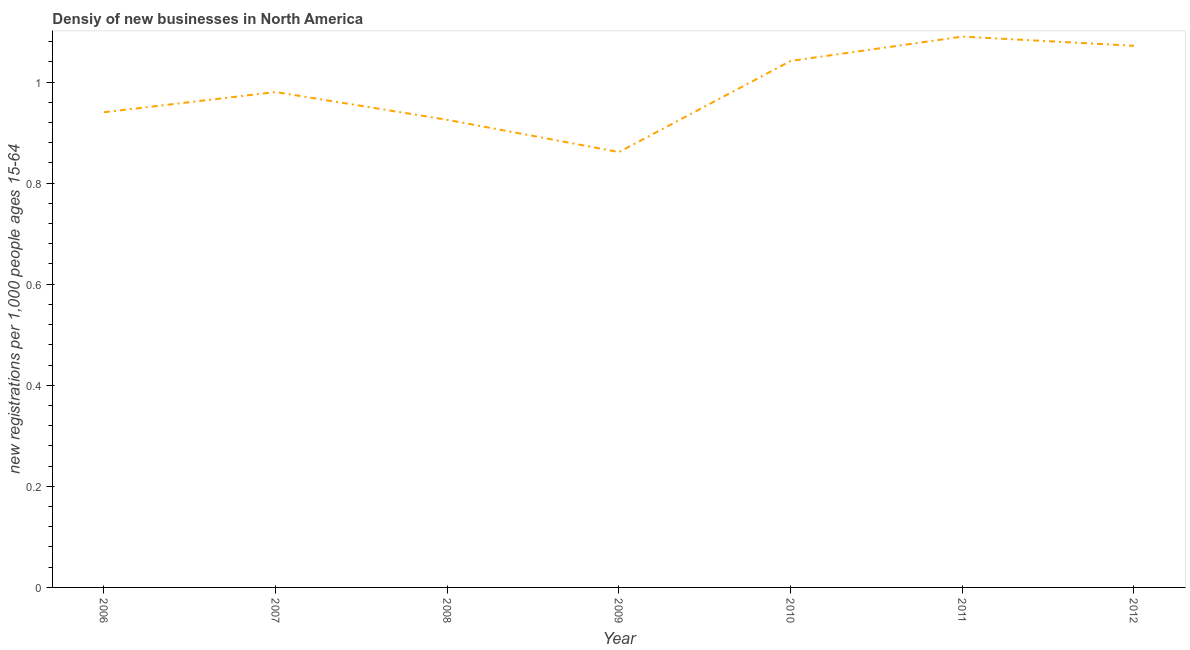What is the density of new business in 2012?
Your response must be concise. 1.07. Across all years, what is the maximum density of new business?
Your response must be concise. 1.09. Across all years, what is the minimum density of new business?
Provide a short and direct response. 0.86. What is the sum of the density of new business?
Keep it short and to the point. 6.91. What is the difference between the density of new business in 2008 and 2011?
Offer a very short reply. -0.16. What is the average density of new business per year?
Provide a short and direct response. 0.99. What is the median density of new business?
Give a very brief answer. 0.98. What is the ratio of the density of new business in 2007 to that in 2011?
Ensure brevity in your answer.  0.9. Is the density of new business in 2008 less than that in 2010?
Offer a very short reply. Yes. Is the difference between the density of new business in 2008 and 2009 greater than the difference between any two years?
Offer a terse response. No. What is the difference between the highest and the second highest density of new business?
Your answer should be very brief. 0.02. Is the sum of the density of new business in 2007 and 2012 greater than the maximum density of new business across all years?
Ensure brevity in your answer.  Yes. What is the difference between the highest and the lowest density of new business?
Offer a very short reply. 0.23. In how many years, is the density of new business greater than the average density of new business taken over all years?
Provide a succinct answer. 3. Does the density of new business monotonically increase over the years?
Your response must be concise. No. What is the difference between two consecutive major ticks on the Y-axis?
Your answer should be compact. 0.2. Does the graph contain grids?
Your answer should be compact. No. What is the title of the graph?
Your answer should be compact. Densiy of new businesses in North America. What is the label or title of the Y-axis?
Offer a very short reply. New registrations per 1,0 people ages 15-64. What is the new registrations per 1,000 people ages 15-64 of 2006?
Offer a very short reply. 0.94. What is the new registrations per 1,000 people ages 15-64 in 2007?
Ensure brevity in your answer.  0.98. What is the new registrations per 1,000 people ages 15-64 of 2008?
Your answer should be compact. 0.93. What is the new registrations per 1,000 people ages 15-64 in 2009?
Keep it short and to the point. 0.86. What is the new registrations per 1,000 people ages 15-64 in 2010?
Offer a very short reply. 1.04. What is the new registrations per 1,000 people ages 15-64 in 2011?
Provide a succinct answer. 1.09. What is the new registrations per 1,000 people ages 15-64 in 2012?
Provide a short and direct response. 1.07. What is the difference between the new registrations per 1,000 people ages 15-64 in 2006 and 2007?
Offer a terse response. -0.04. What is the difference between the new registrations per 1,000 people ages 15-64 in 2006 and 2008?
Your response must be concise. 0.02. What is the difference between the new registrations per 1,000 people ages 15-64 in 2006 and 2009?
Provide a short and direct response. 0.08. What is the difference between the new registrations per 1,000 people ages 15-64 in 2006 and 2010?
Offer a terse response. -0.1. What is the difference between the new registrations per 1,000 people ages 15-64 in 2006 and 2011?
Your answer should be very brief. -0.15. What is the difference between the new registrations per 1,000 people ages 15-64 in 2006 and 2012?
Ensure brevity in your answer.  -0.13. What is the difference between the new registrations per 1,000 people ages 15-64 in 2007 and 2008?
Offer a terse response. 0.06. What is the difference between the new registrations per 1,000 people ages 15-64 in 2007 and 2009?
Provide a succinct answer. 0.12. What is the difference between the new registrations per 1,000 people ages 15-64 in 2007 and 2010?
Ensure brevity in your answer.  -0.06. What is the difference between the new registrations per 1,000 people ages 15-64 in 2007 and 2011?
Provide a short and direct response. -0.11. What is the difference between the new registrations per 1,000 people ages 15-64 in 2007 and 2012?
Offer a very short reply. -0.09. What is the difference between the new registrations per 1,000 people ages 15-64 in 2008 and 2009?
Ensure brevity in your answer.  0.06. What is the difference between the new registrations per 1,000 people ages 15-64 in 2008 and 2010?
Give a very brief answer. -0.12. What is the difference between the new registrations per 1,000 people ages 15-64 in 2008 and 2011?
Your response must be concise. -0.16. What is the difference between the new registrations per 1,000 people ages 15-64 in 2008 and 2012?
Ensure brevity in your answer.  -0.15. What is the difference between the new registrations per 1,000 people ages 15-64 in 2009 and 2010?
Your answer should be compact. -0.18. What is the difference between the new registrations per 1,000 people ages 15-64 in 2009 and 2011?
Your answer should be very brief. -0.23. What is the difference between the new registrations per 1,000 people ages 15-64 in 2009 and 2012?
Keep it short and to the point. -0.21. What is the difference between the new registrations per 1,000 people ages 15-64 in 2010 and 2011?
Your response must be concise. -0.05. What is the difference between the new registrations per 1,000 people ages 15-64 in 2010 and 2012?
Offer a very short reply. -0.03. What is the difference between the new registrations per 1,000 people ages 15-64 in 2011 and 2012?
Give a very brief answer. 0.02. What is the ratio of the new registrations per 1,000 people ages 15-64 in 2006 to that in 2007?
Your answer should be compact. 0.96. What is the ratio of the new registrations per 1,000 people ages 15-64 in 2006 to that in 2009?
Give a very brief answer. 1.09. What is the ratio of the new registrations per 1,000 people ages 15-64 in 2006 to that in 2010?
Keep it short and to the point. 0.9. What is the ratio of the new registrations per 1,000 people ages 15-64 in 2006 to that in 2011?
Your response must be concise. 0.86. What is the ratio of the new registrations per 1,000 people ages 15-64 in 2006 to that in 2012?
Offer a very short reply. 0.88. What is the ratio of the new registrations per 1,000 people ages 15-64 in 2007 to that in 2008?
Keep it short and to the point. 1.06. What is the ratio of the new registrations per 1,000 people ages 15-64 in 2007 to that in 2009?
Provide a short and direct response. 1.14. What is the ratio of the new registrations per 1,000 people ages 15-64 in 2007 to that in 2010?
Provide a succinct answer. 0.94. What is the ratio of the new registrations per 1,000 people ages 15-64 in 2007 to that in 2011?
Provide a short and direct response. 0.9. What is the ratio of the new registrations per 1,000 people ages 15-64 in 2007 to that in 2012?
Provide a succinct answer. 0.92. What is the ratio of the new registrations per 1,000 people ages 15-64 in 2008 to that in 2009?
Offer a very short reply. 1.07. What is the ratio of the new registrations per 1,000 people ages 15-64 in 2008 to that in 2010?
Provide a succinct answer. 0.89. What is the ratio of the new registrations per 1,000 people ages 15-64 in 2008 to that in 2011?
Your response must be concise. 0.85. What is the ratio of the new registrations per 1,000 people ages 15-64 in 2008 to that in 2012?
Keep it short and to the point. 0.86. What is the ratio of the new registrations per 1,000 people ages 15-64 in 2009 to that in 2010?
Your response must be concise. 0.83. What is the ratio of the new registrations per 1,000 people ages 15-64 in 2009 to that in 2011?
Your response must be concise. 0.79. What is the ratio of the new registrations per 1,000 people ages 15-64 in 2009 to that in 2012?
Your response must be concise. 0.8. What is the ratio of the new registrations per 1,000 people ages 15-64 in 2010 to that in 2011?
Your answer should be very brief. 0.96. What is the ratio of the new registrations per 1,000 people ages 15-64 in 2011 to that in 2012?
Your response must be concise. 1.02. 